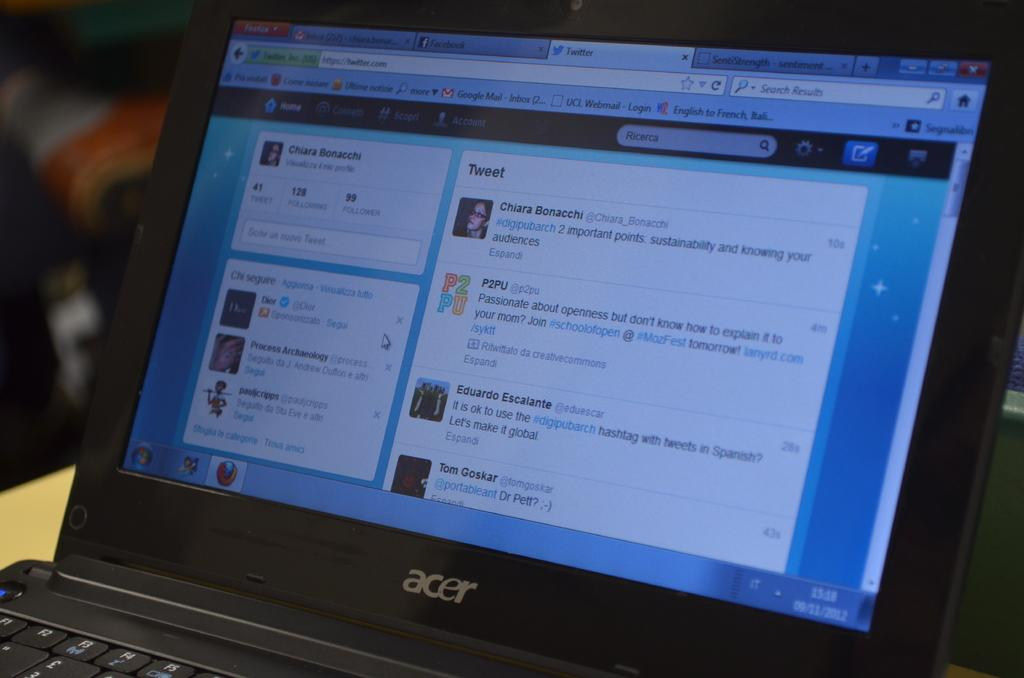<image>
Give a short and clear explanation of the subsequent image. An Acer laptop, currently running a web browser displaying Twitter. 